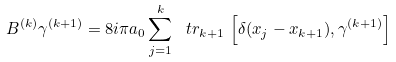Convert formula to latex. <formula><loc_0><loc_0><loc_500><loc_500>B ^ { ( k ) } \gamma ^ { ( k + 1 ) } = 8 i \pi a _ { 0 } \sum _ { j = 1 } ^ { k } \ t r _ { k + 1 } \, \left [ \delta ( x _ { j } - x _ { k + 1 } ) , \gamma ^ { ( k + 1 ) } \right ]</formula> 